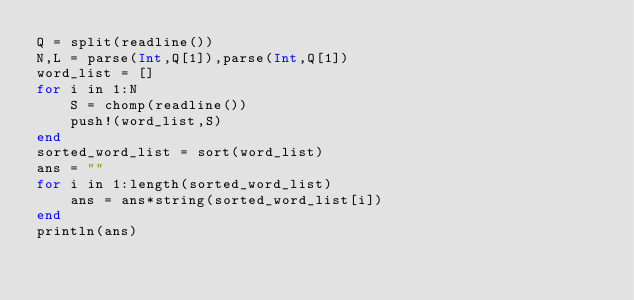<code> <loc_0><loc_0><loc_500><loc_500><_Julia_>Q = split(readline())
N,L = parse(Int,Q[1]),parse(Int,Q[1])
word_list = []
for i in 1:N
    S = chomp(readline())
    push!(word_list,S)
end
sorted_word_list = sort(word_list)
ans = ""
for i in 1:length(sorted_word_list)
    ans = ans*string(sorted_word_list[i])
end
println(ans)</code> 